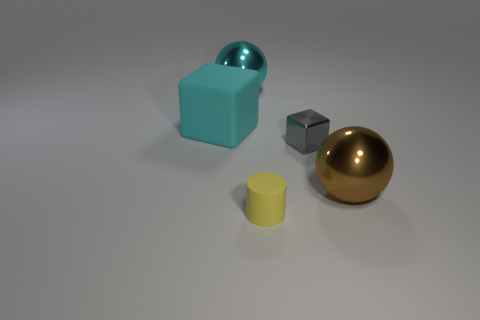Do the metallic cube and the brown thing have the same size?
Offer a terse response. No. Is there any other thing that has the same size as the brown thing?
Keep it short and to the point. Yes. What is the color of the cube that is the same material as the cylinder?
Give a very brief answer. Cyan. Is the number of things that are on the right side of the yellow rubber object less than the number of yellow matte objects that are to the left of the cyan metallic sphere?
Offer a very short reply. No. What number of large spheres have the same color as the tiny shiny block?
Make the answer very short. 0. There is a ball that is the same color as the rubber cube; what material is it?
Your answer should be very brief. Metal. What number of objects are both in front of the tiny gray metallic block and right of the small rubber thing?
Your answer should be very brief. 1. There is a sphere that is to the right of the ball that is to the left of the brown shiny ball; what is its material?
Ensure brevity in your answer.  Metal. Are there any large yellow things made of the same material as the small gray block?
Provide a short and direct response. No. There is a cyan sphere that is the same size as the brown sphere; what is it made of?
Offer a very short reply. Metal. 